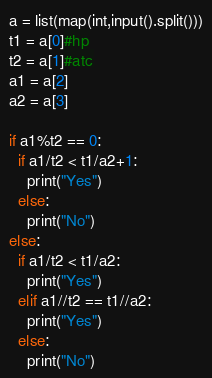<code> <loc_0><loc_0><loc_500><loc_500><_Python_>a = list(map(int,input().split()))
t1 = a[0]#hp
t2 = a[1]#atc
a1 = a[2]
a2 = a[3]

if a1%t2 == 0:
  if a1/t2 < t1/a2+1:
    print("Yes")
  else:
    print("No")
else:
  if a1/t2 < t1/a2:
    print("Yes")
  elif a1//t2 == t1//a2:
    print("Yes")
  else:
    print("No")</code> 